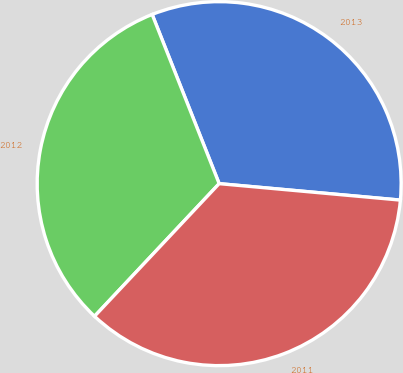Convert chart to OTSL. <chart><loc_0><loc_0><loc_500><loc_500><pie_chart><fcel>2013<fcel>2012<fcel>2011<nl><fcel>32.44%<fcel>31.99%<fcel>35.56%<nl></chart> 